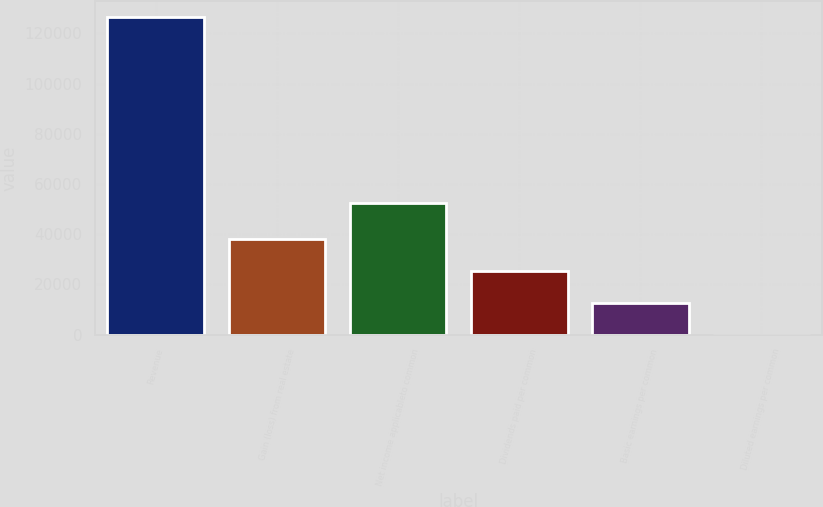Convert chart to OTSL. <chart><loc_0><loc_0><loc_500><loc_500><bar_chart><fcel>Revenue<fcel>Gain (loss) from real estate<fcel>Net income applicableto common<fcel>Dividends paid per common<fcel>Basic earnings per common<fcel>Diluted earnings per common<nl><fcel>126458<fcel>37937.7<fcel>52605<fcel>25291.9<fcel>12646.1<fcel>0.38<nl></chart> 